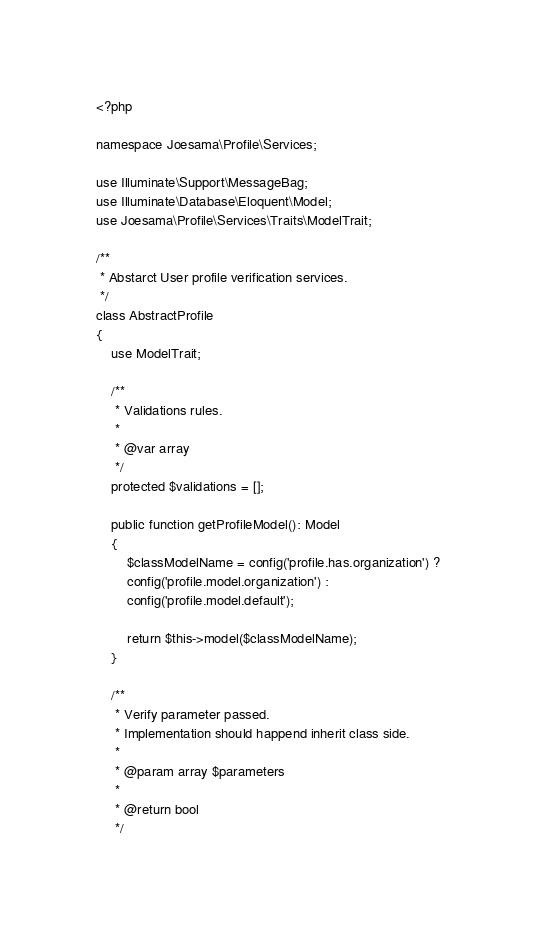<code> <loc_0><loc_0><loc_500><loc_500><_PHP_><?php

namespace Joesama\Profile\Services;

use Illuminate\Support\MessageBag;
use Illuminate\Database\Eloquent\Model;
use Joesama\Profile\Services\Traits\ModelTrait;

/**
 * Abstarct User profile verification services.
 */
class AbstractProfile
{
    use ModelTrait;

    /**
     * Validations rules.
     *
     * @var array
     */
    protected $validations = [];

    public function getProfileModel(): Model
    {
        $classModelName = config('profile.has.organization') ?
        config('profile.model.organization') :
        config('profile.model.default');

        return $this->model($classModelName);
    }
    
    /**
     * Verify parameter passed.
     * Implementation should happend inherit class side.
     *
     * @param array $parameters
     *
     * @return bool
     */</code> 